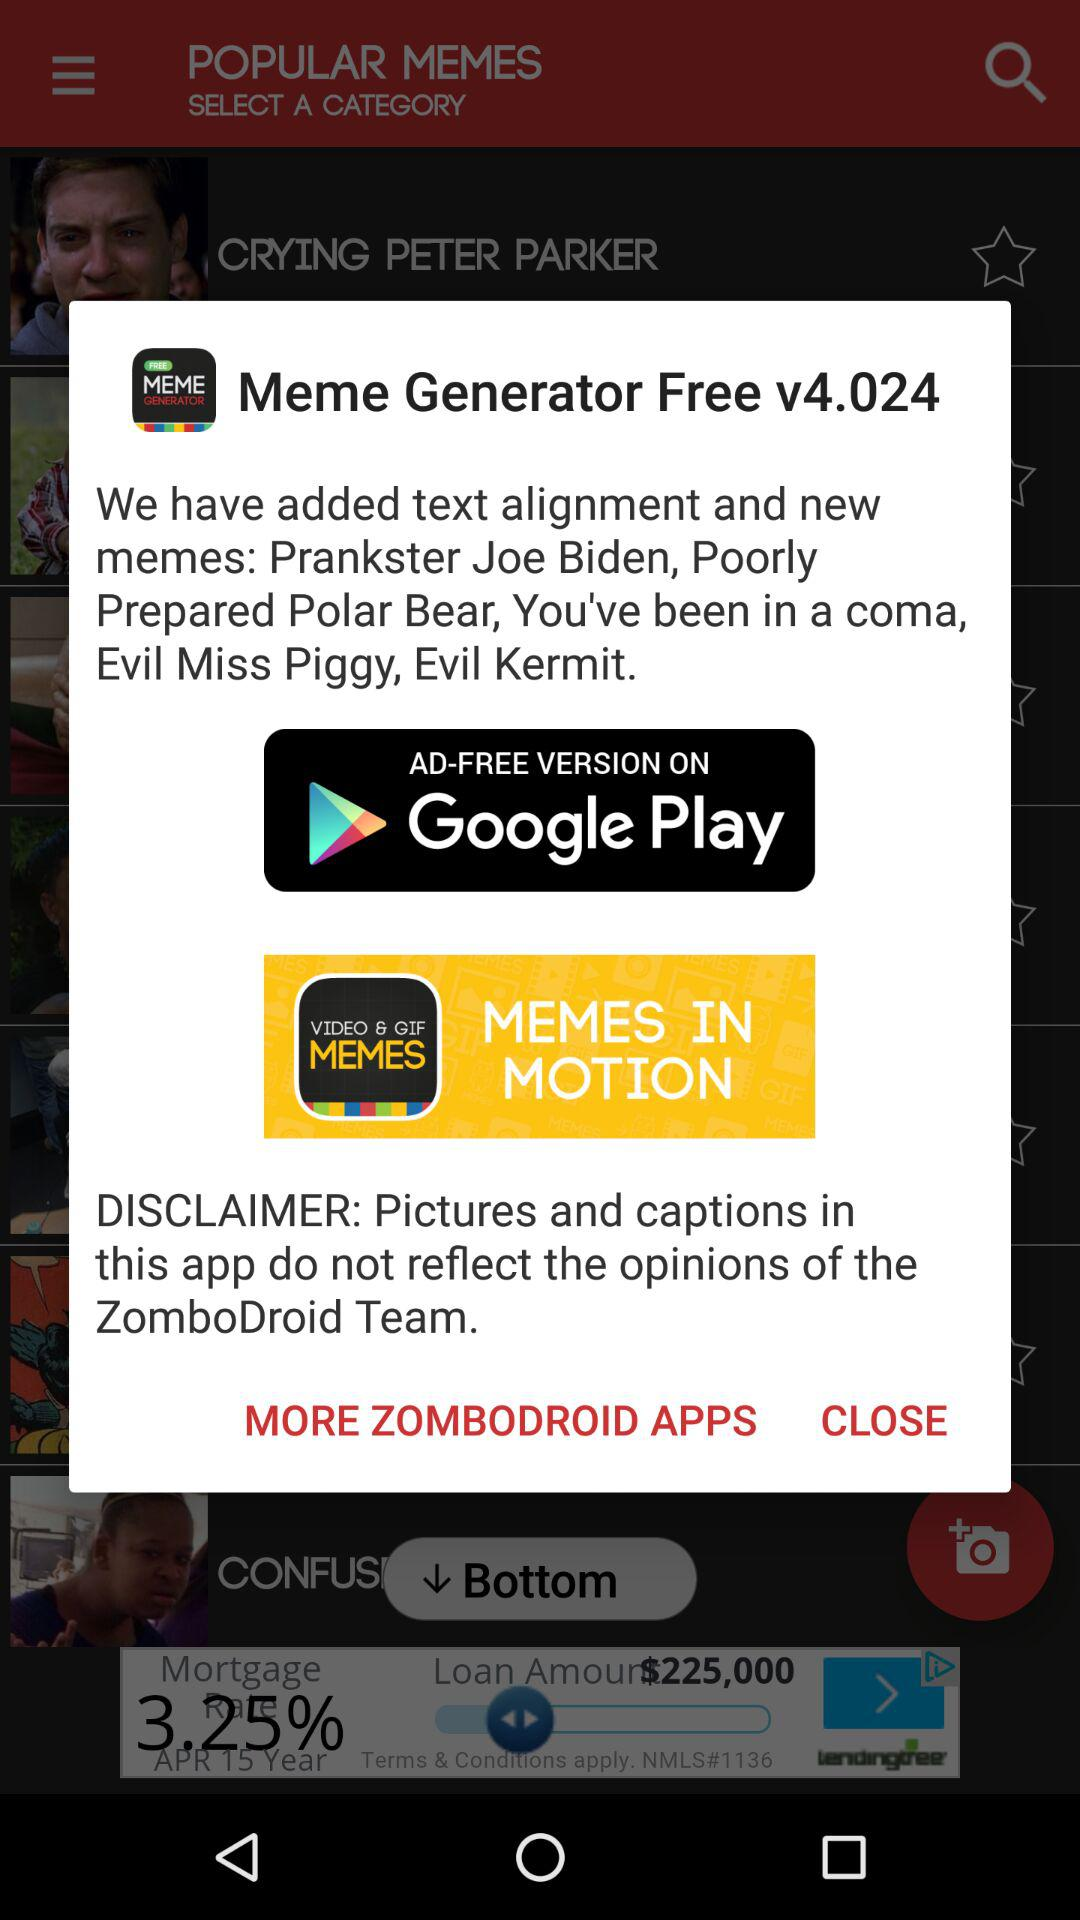What is the application name? The application name is "Meme Generator". 